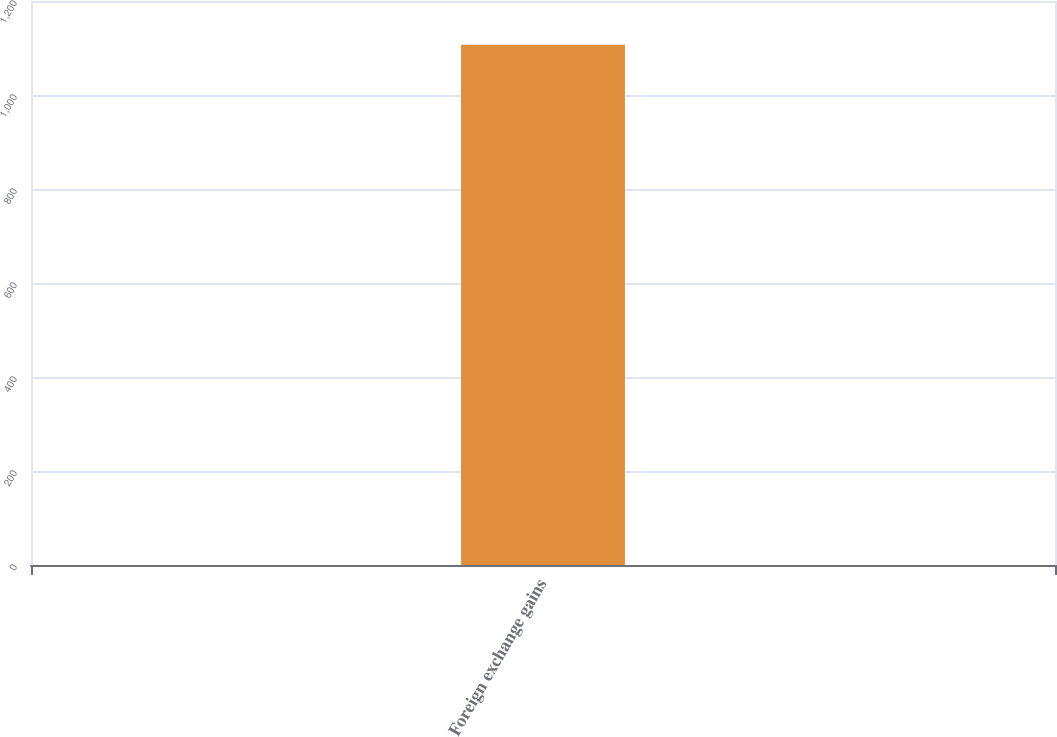Convert chart to OTSL. <chart><loc_0><loc_0><loc_500><loc_500><bar_chart><fcel>Foreign exchange gains<nl><fcel>1107.1<nl></chart> 